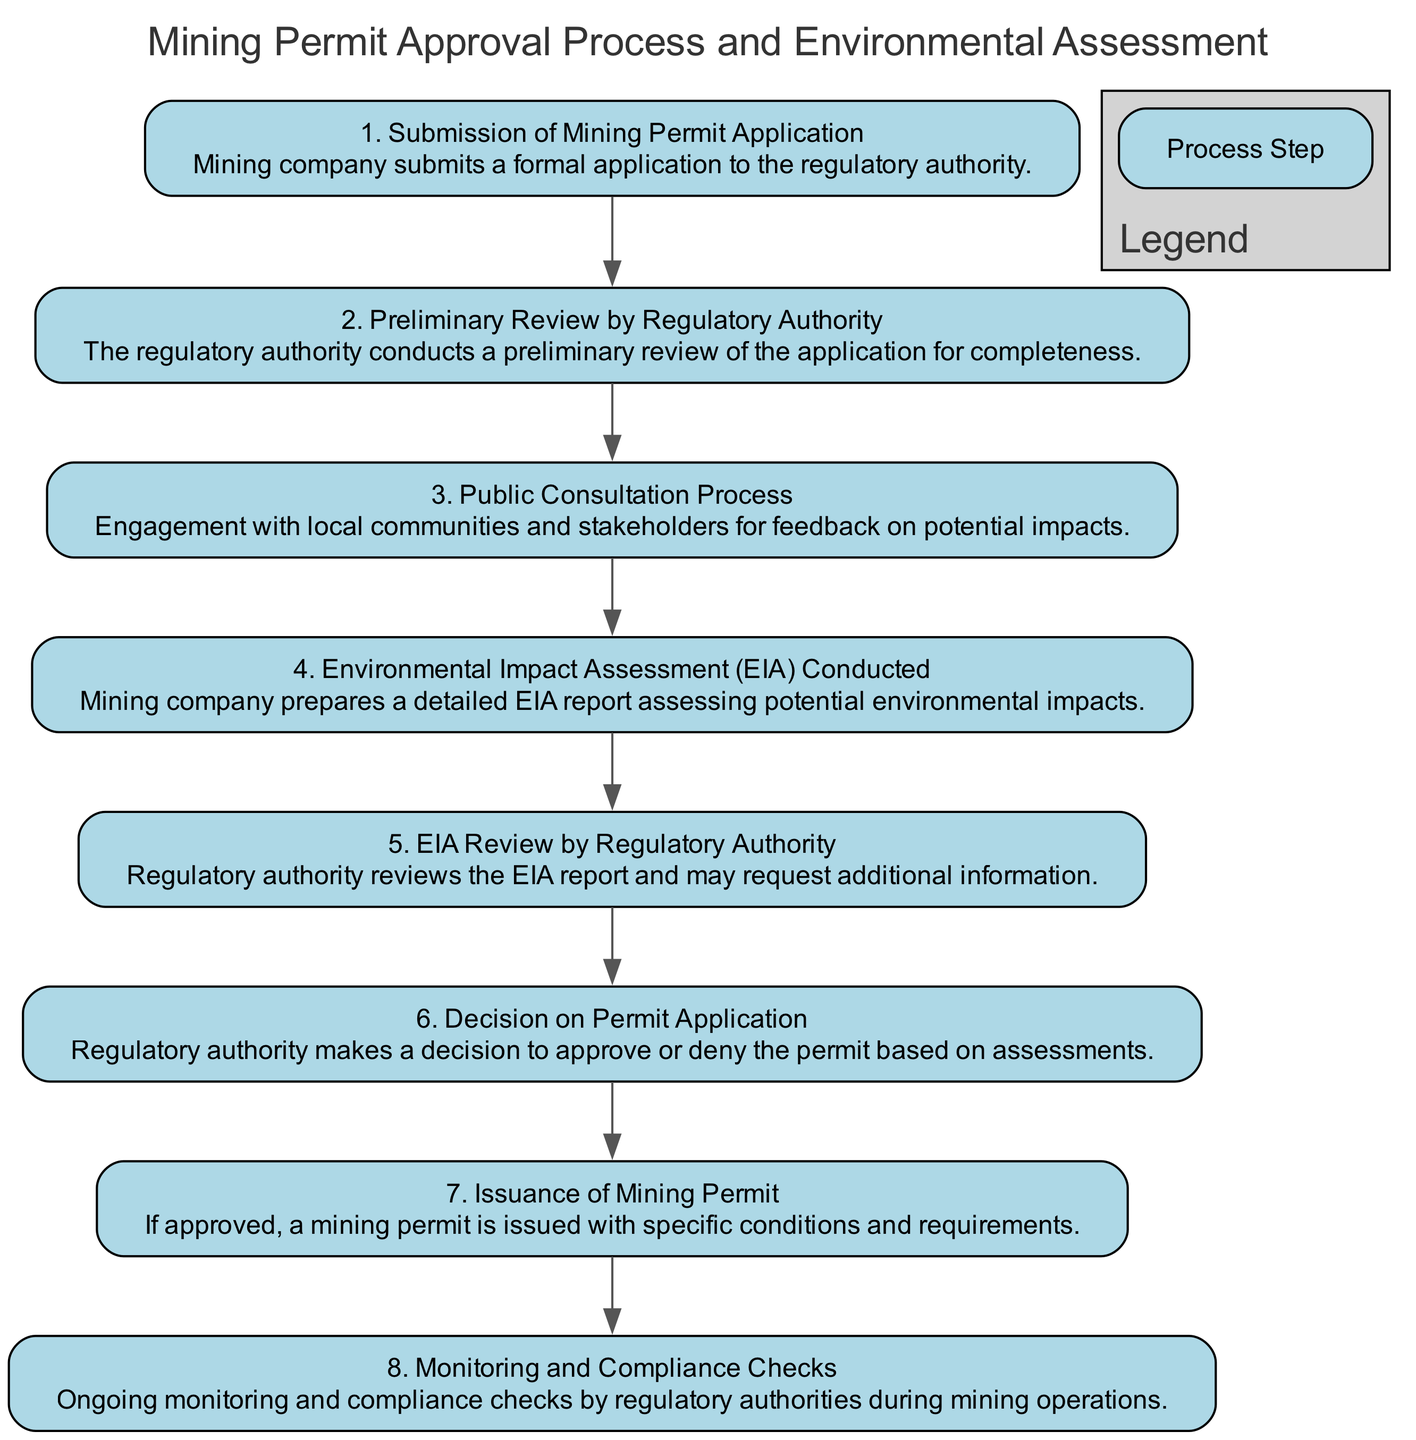What is the first step in the process? The first step in the diagram is "Submission of Mining Permit Application," which is the initial action taken by the mining company to start the approval process.
Answer: Submission of Mining Permit Application How many steps are there in total? Counting all the steps in the diagram, there are eight distinct steps listed in the mining permit approval process.
Answer: 8 What follows after the "Preliminary Review by Regulatory Authority"? After the "Preliminary Review by Regulatory Authority," the next step is "Public Consultation Process," indicating engagement with stakeholders for feedback.
Answer: Public Consultation Process Which step involves community engagement? The "Public Consultation Process" is specifically focused on engaging with local communities and stakeholders for their feedback on potential impacts.
Answer: Public Consultation Process What is the final step in the approval process? The last step in the process is "Monitoring and Compliance Checks," which entails ongoing oversight by regulatory authorities during mining operations to ensure adherence to regulations.
Answer: Monitoring and Compliance Checks What occurs right before the "Issuance of Mining Permit"? Before the "Issuance of Mining Permit," the "Decision on Permit Application" is made by the regulatory authority to either approve or deny the permit.
Answer: Decision on Permit Application How many review stages are there for the Environmental Impact Assessment? There are two review stages specifically for the Environmental Impact Assessment: the "EIA Conducted" by the mining company and the "EIA Review by Regulatory Authority" for assessing the report.
Answer: 2 What document is prepared by the mining company? The mining company prepares a detailed "Environmental Impact Assessment (EIA) report" to evaluate potential environmental impacts as part of the approval process.
Answer: Environmental Impact Assessment (EIA) report Which step involves the issuance of conditions and requirements? The step titled "Issuance of Mining Permit" includes the issuance of specific conditions and requirements if the permit is approved by the regulatory authority.
Answer: Issuance of Mining Permit 